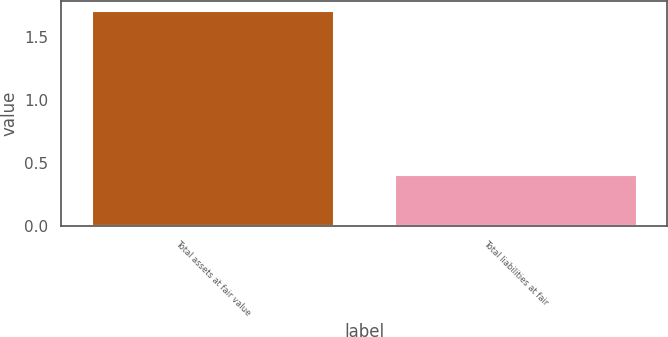Convert chart. <chart><loc_0><loc_0><loc_500><loc_500><bar_chart><fcel>Total assets at fair value<fcel>Total liabilities at fair<nl><fcel>1.7<fcel>0.4<nl></chart> 